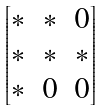<formula> <loc_0><loc_0><loc_500><loc_500>\begin{bmatrix} * & * & 0 \\ * & * & * \\ * & 0 & 0 \end{bmatrix}</formula> 